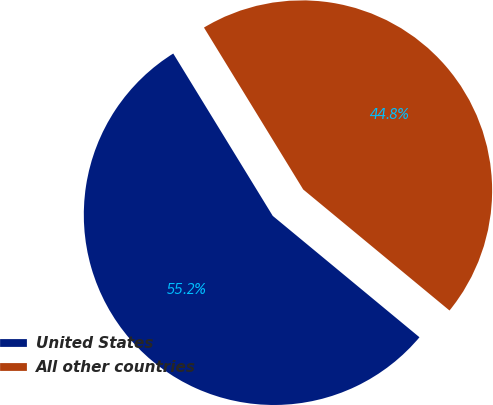<chart> <loc_0><loc_0><loc_500><loc_500><pie_chart><fcel>United States<fcel>All other countries<nl><fcel>55.25%<fcel>44.75%<nl></chart> 